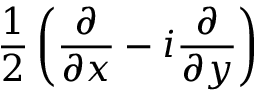Convert formula to latex. <formula><loc_0><loc_0><loc_500><loc_500>\frac { 1 } { 2 } \left ( \frac { \partial } { \partial x } - i \frac { \partial } { \partial y } \right )</formula> 